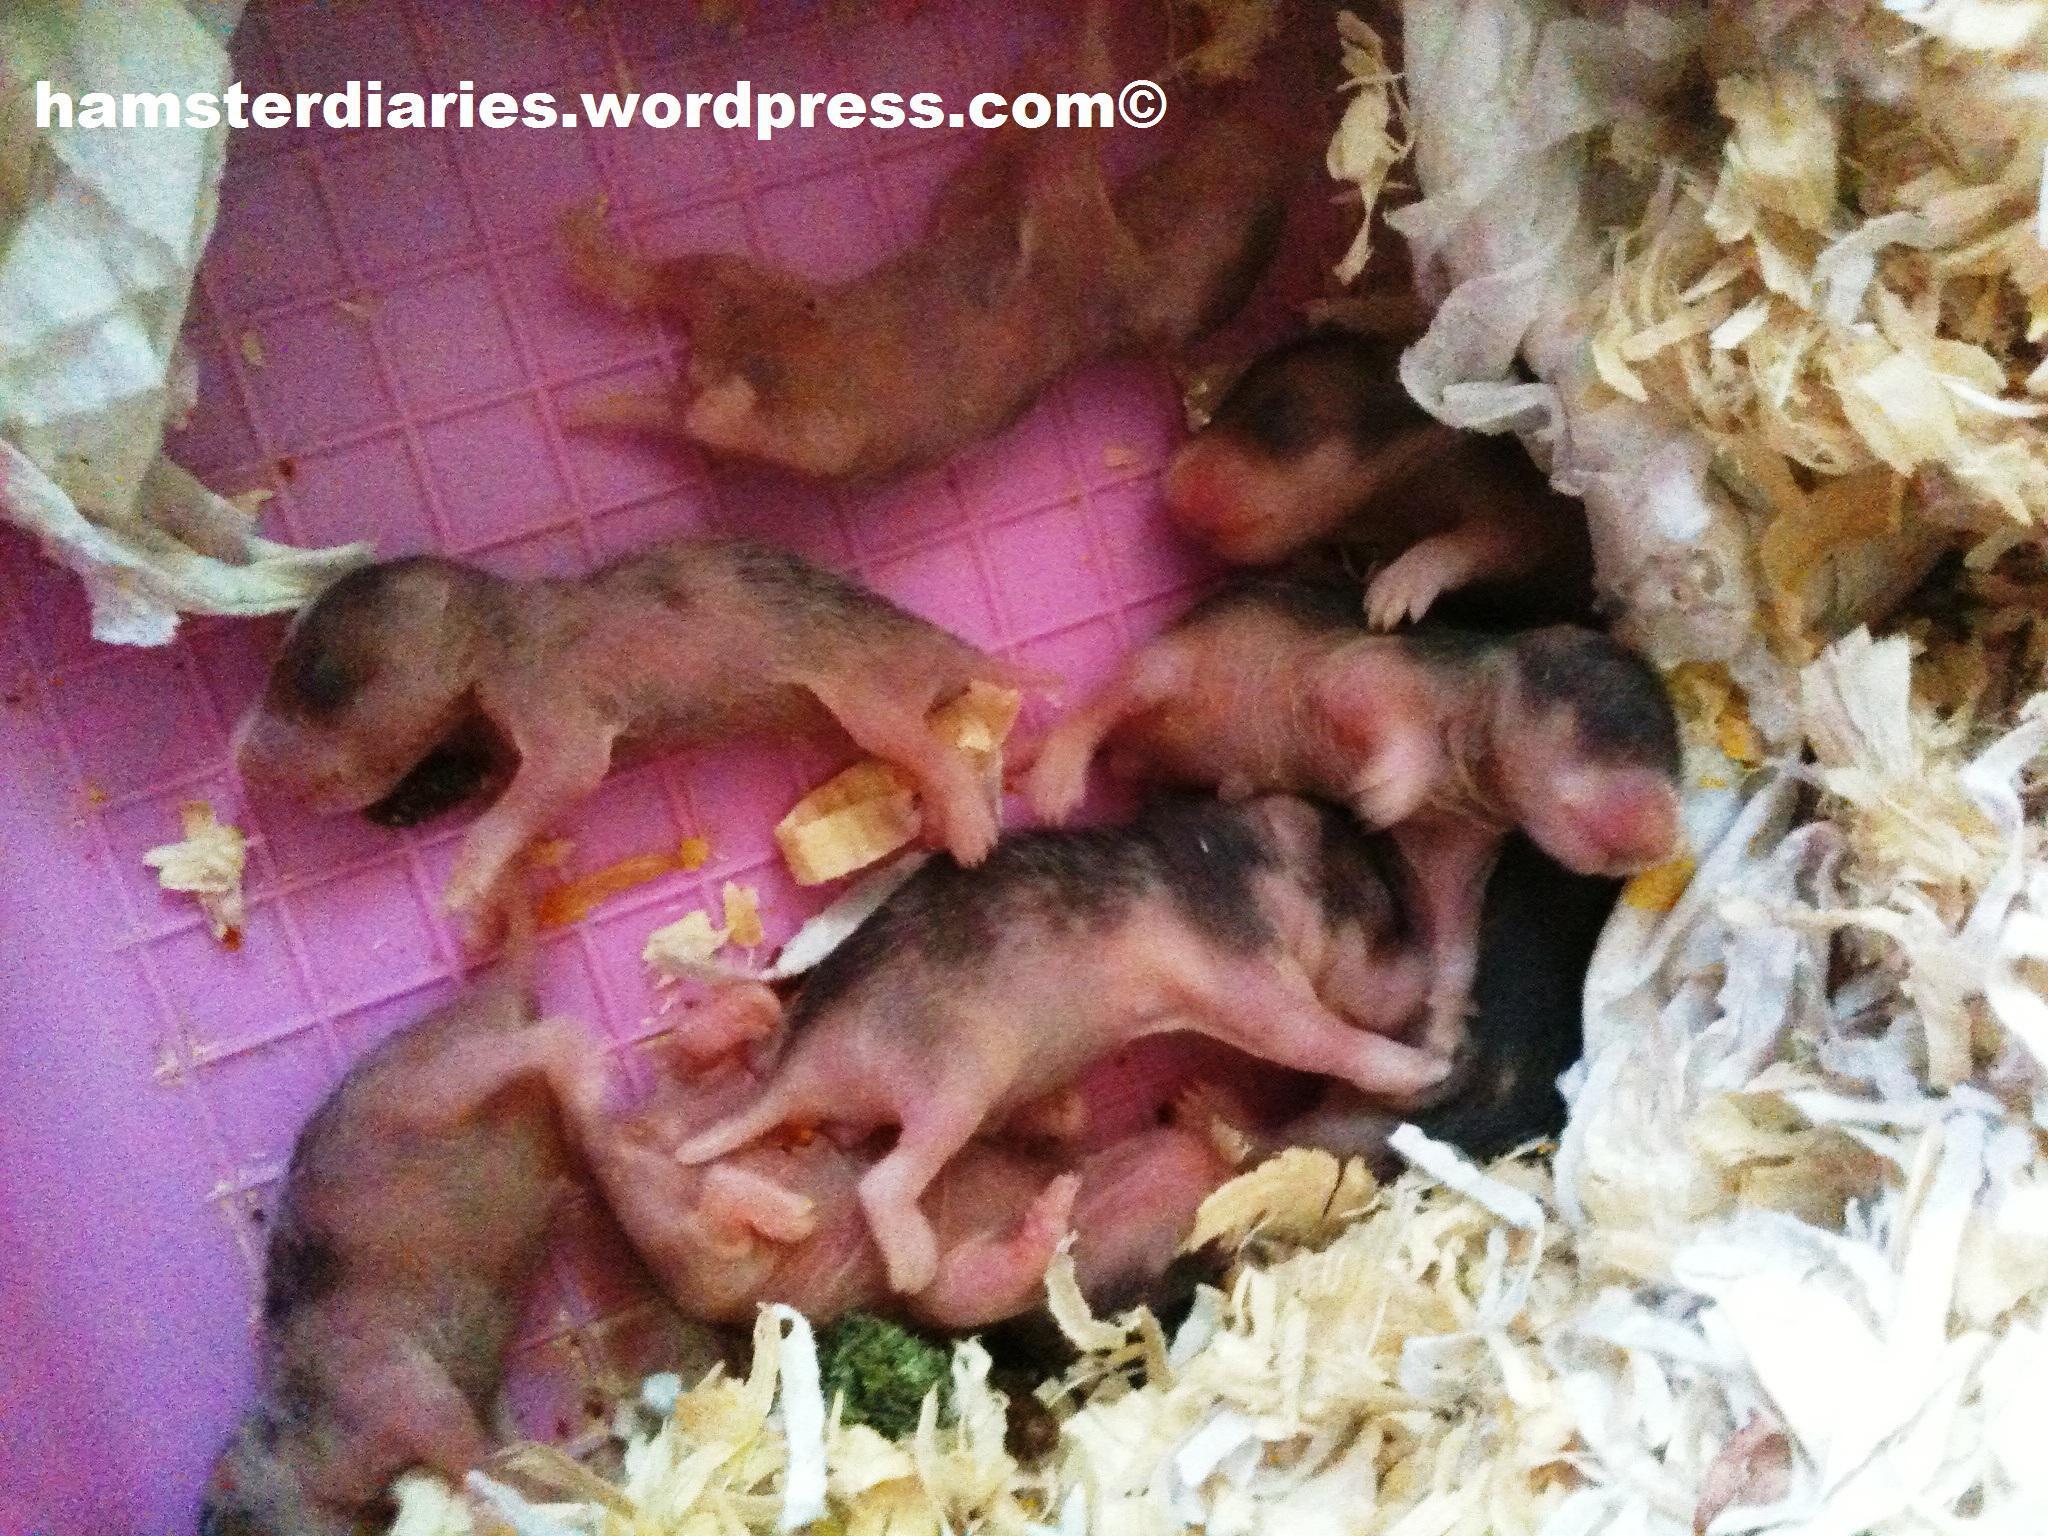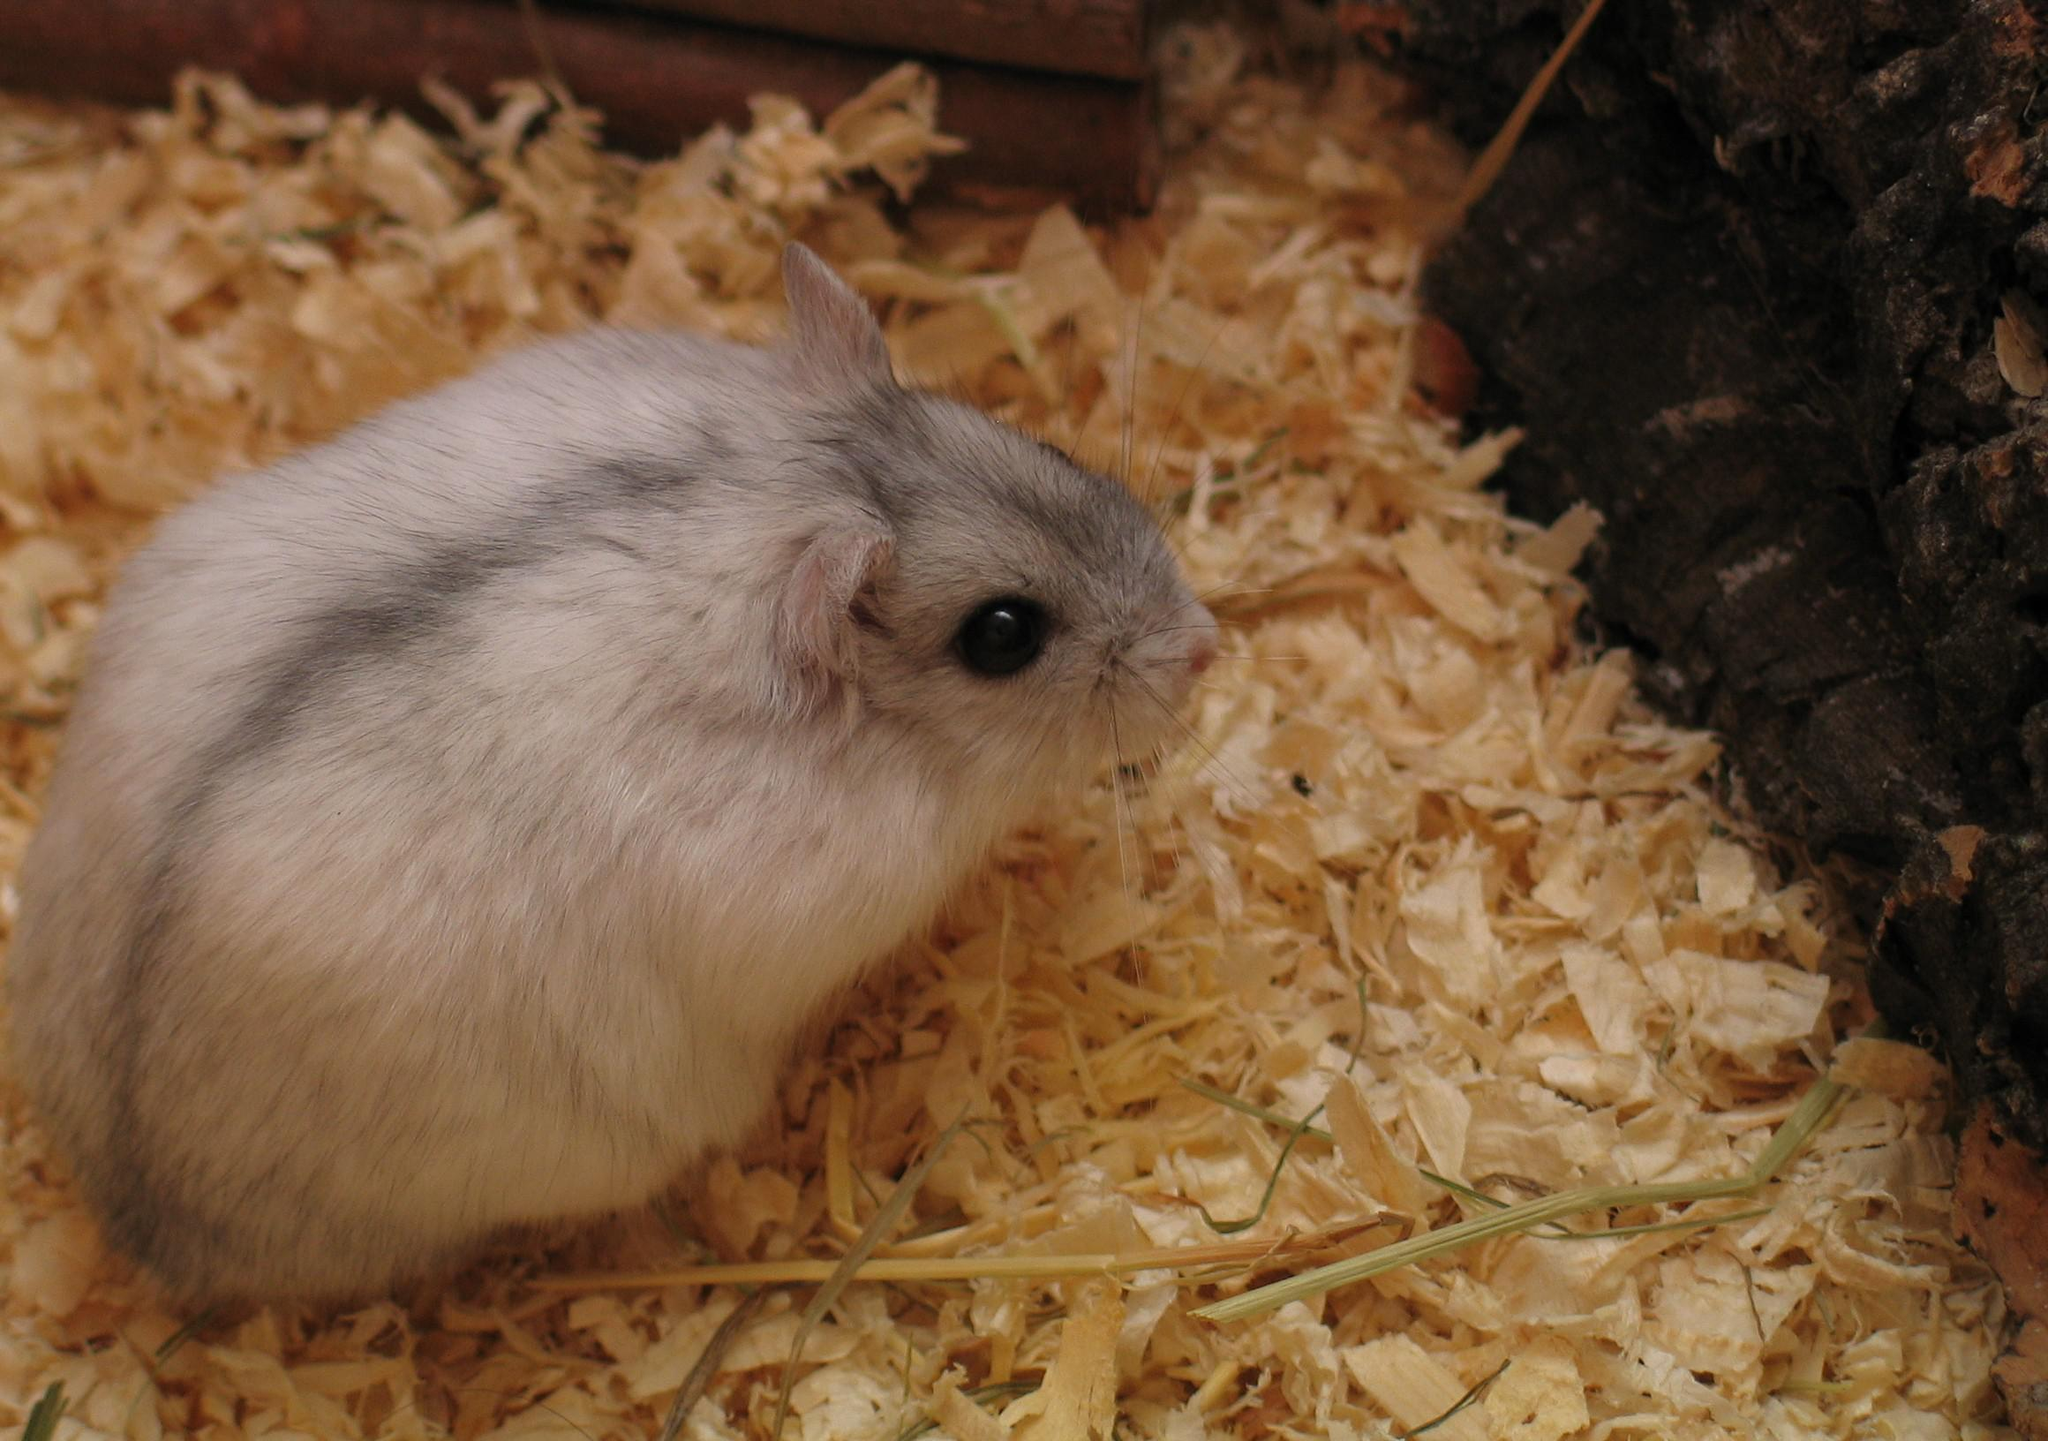The first image is the image on the left, the second image is the image on the right. For the images shown, is this caption "the image on the right contains a single animal" true? Answer yes or no. Yes. The first image is the image on the left, the second image is the image on the right. Given the left and right images, does the statement "There are several hairless newborn hamsters in one of the images." hold true? Answer yes or no. Yes. 